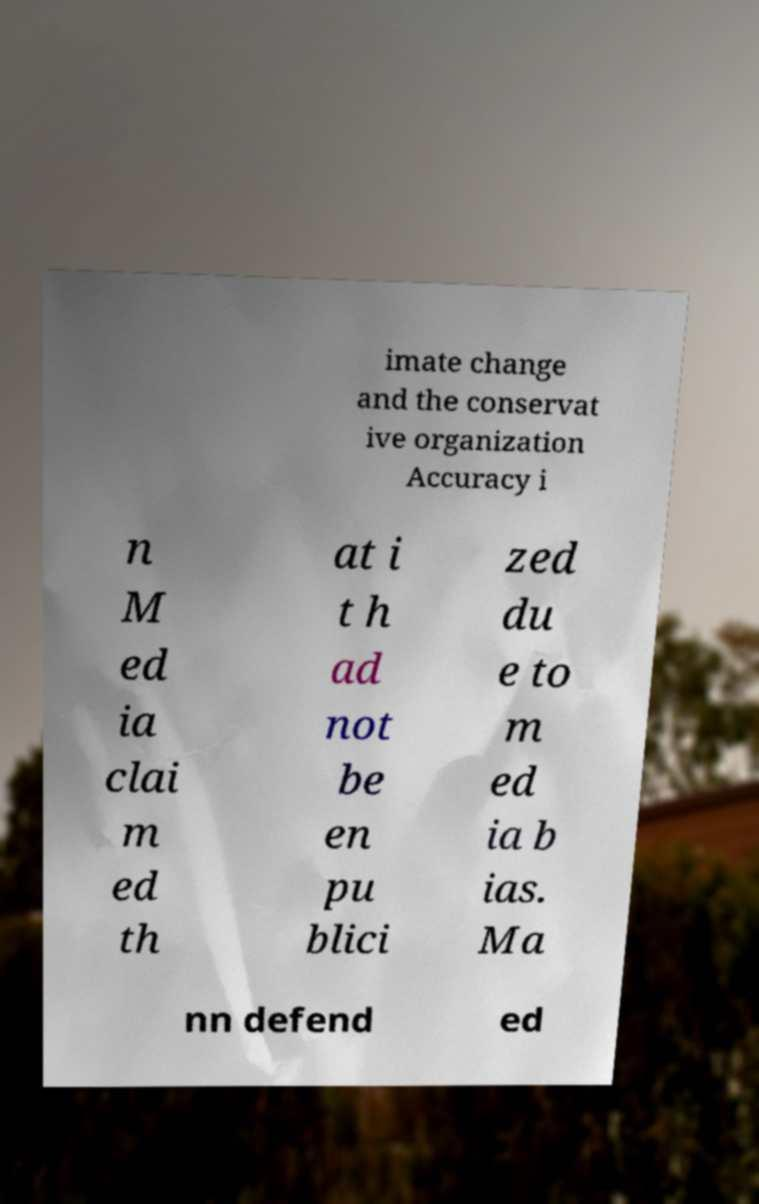For documentation purposes, I need the text within this image transcribed. Could you provide that? imate change and the conservat ive organization Accuracy i n M ed ia clai m ed th at i t h ad not be en pu blici zed du e to m ed ia b ias. Ma nn defend ed 